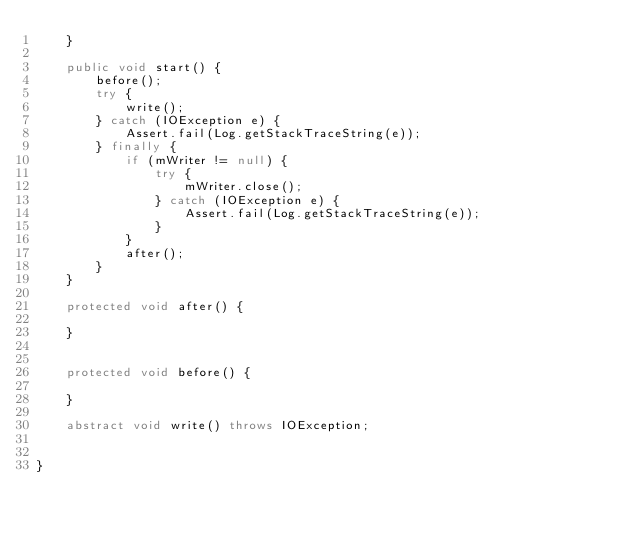<code> <loc_0><loc_0><loc_500><loc_500><_Java_>    }

    public void start() {
        before();
        try {
            write();
        } catch (IOException e) {
            Assert.fail(Log.getStackTraceString(e));
        } finally {
            if (mWriter != null) {
                try {
                    mWriter.close();
                } catch (IOException e) {
                    Assert.fail(Log.getStackTraceString(e));
                }
            }
            after();
        }
    }

    protected void after() {

    }


    protected void before() {

    }

    abstract void write() throws IOException;


}
</code> 